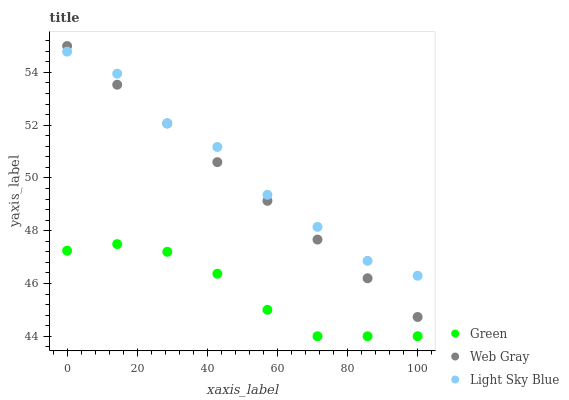Does Green have the minimum area under the curve?
Answer yes or no. Yes. Does Light Sky Blue have the maximum area under the curve?
Answer yes or no. Yes. Does Light Sky Blue have the minimum area under the curve?
Answer yes or no. No. Does Green have the maximum area under the curve?
Answer yes or no. No. Is Web Gray the smoothest?
Answer yes or no. Yes. Is Light Sky Blue the roughest?
Answer yes or no. Yes. Is Green the smoothest?
Answer yes or no. No. Is Green the roughest?
Answer yes or no. No. Does Green have the lowest value?
Answer yes or no. Yes. Does Light Sky Blue have the lowest value?
Answer yes or no. No. Does Web Gray have the highest value?
Answer yes or no. Yes. Does Light Sky Blue have the highest value?
Answer yes or no. No. Is Green less than Web Gray?
Answer yes or no. Yes. Is Web Gray greater than Green?
Answer yes or no. Yes. Does Web Gray intersect Light Sky Blue?
Answer yes or no. Yes. Is Web Gray less than Light Sky Blue?
Answer yes or no. No. Is Web Gray greater than Light Sky Blue?
Answer yes or no. No. Does Green intersect Web Gray?
Answer yes or no. No. 